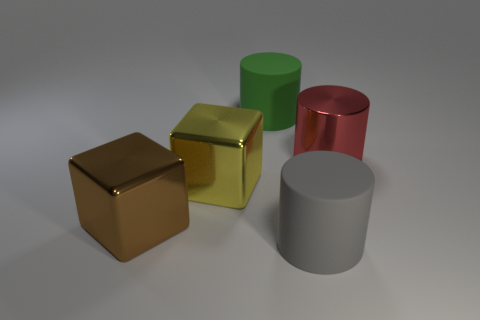What color is the large rubber cylinder that is behind the red metallic cylinder?
Offer a terse response. Green. What number of big blocks are behind the big shiny object right of the large cylinder that is left of the big gray thing?
Make the answer very short. 0. What number of brown metallic cubes are on the right side of the large rubber object left of the big gray rubber cylinder?
Offer a very short reply. 0. How many big green matte things are in front of the big yellow shiny thing?
Your response must be concise. 0. What number of other objects are the same size as the green matte cylinder?
Give a very brief answer. 4. The gray matte object that is the same shape as the large red thing is what size?
Offer a terse response. Large. The large shiny object to the right of the green cylinder has what shape?
Your answer should be very brief. Cylinder. There is a large rubber cylinder to the right of the matte cylinder that is behind the big yellow metal object; what is its color?
Your answer should be compact. Gray. What number of things are either gray things that are right of the green object or big gray matte cylinders?
Your answer should be very brief. 1. Does the red shiny cylinder have the same size as the object that is behind the big red metallic thing?
Make the answer very short. Yes. 